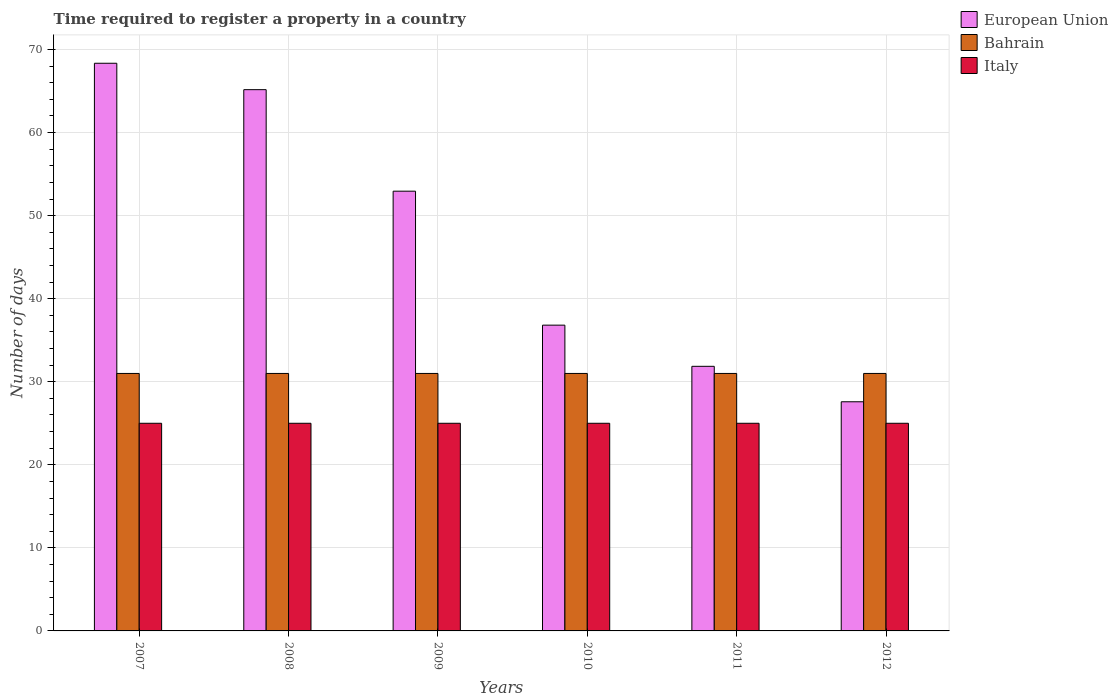How many groups of bars are there?
Offer a terse response. 6. How many bars are there on the 6th tick from the left?
Ensure brevity in your answer.  3. How many bars are there on the 6th tick from the right?
Keep it short and to the point. 3. What is the label of the 2nd group of bars from the left?
Your response must be concise. 2008. Across all years, what is the maximum number of days required to register a property in Bahrain?
Your answer should be very brief. 31. Across all years, what is the minimum number of days required to register a property in European Union?
Your response must be concise. 27.59. In which year was the number of days required to register a property in Italy maximum?
Ensure brevity in your answer.  2007. What is the total number of days required to register a property in European Union in the graph?
Your response must be concise. 282.72. What is the difference between the number of days required to register a property in Bahrain in 2009 and that in 2010?
Give a very brief answer. 0. What is the difference between the number of days required to register a property in Italy in 2007 and the number of days required to register a property in European Union in 2010?
Make the answer very short. -11.81. In the year 2008, what is the difference between the number of days required to register a property in European Union and number of days required to register a property in Bahrain?
Offer a terse response. 34.17. What is the ratio of the number of days required to register a property in European Union in 2011 to that in 2012?
Your response must be concise. 1.15. Is the number of days required to register a property in Italy in 2008 less than that in 2010?
Your answer should be very brief. No. Is the difference between the number of days required to register a property in European Union in 2007 and 2012 greater than the difference between the number of days required to register a property in Bahrain in 2007 and 2012?
Provide a succinct answer. Yes. What is the difference between the highest and the second highest number of days required to register a property in Bahrain?
Give a very brief answer. 0. What is the difference between the highest and the lowest number of days required to register a property in Italy?
Provide a succinct answer. 0. Is the sum of the number of days required to register a property in Bahrain in 2011 and 2012 greater than the maximum number of days required to register a property in Italy across all years?
Offer a very short reply. Yes. Is it the case that in every year, the sum of the number of days required to register a property in Italy and number of days required to register a property in European Union is greater than the number of days required to register a property in Bahrain?
Keep it short and to the point. Yes. How many bars are there?
Provide a succinct answer. 18. Are all the bars in the graph horizontal?
Ensure brevity in your answer.  No. How many years are there in the graph?
Your answer should be compact. 6. How many legend labels are there?
Make the answer very short. 3. What is the title of the graph?
Offer a very short reply. Time required to register a property in a country. What is the label or title of the X-axis?
Provide a succinct answer. Years. What is the label or title of the Y-axis?
Ensure brevity in your answer.  Number of days. What is the Number of days of European Union in 2007?
Keep it short and to the point. 68.35. What is the Number of days in Bahrain in 2007?
Your response must be concise. 31. What is the Number of days of Italy in 2007?
Your response must be concise. 25. What is the Number of days of European Union in 2008?
Offer a very short reply. 65.17. What is the Number of days in Italy in 2008?
Provide a short and direct response. 25. What is the Number of days of European Union in 2009?
Provide a short and direct response. 52.94. What is the Number of days of Bahrain in 2009?
Your answer should be compact. 31. What is the Number of days in Italy in 2009?
Make the answer very short. 25. What is the Number of days in European Union in 2010?
Your response must be concise. 36.81. What is the Number of days in European Union in 2011?
Your answer should be compact. 31.86. What is the Number of days of Italy in 2011?
Provide a succinct answer. 25. What is the Number of days of European Union in 2012?
Give a very brief answer. 27.59. Across all years, what is the maximum Number of days in European Union?
Your response must be concise. 68.35. Across all years, what is the minimum Number of days in European Union?
Provide a short and direct response. 27.59. Across all years, what is the minimum Number of days in Bahrain?
Offer a terse response. 31. Across all years, what is the minimum Number of days in Italy?
Your response must be concise. 25. What is the total Number of days in European Union in the graph?
Provide a short and direct response. 282.72. What is the total Number of days of Bahrain in the graph?
Your answer should be compact. 186. What is the total Number of days of Italy in the graph?
Make the answer very short. 150. What is the difference between the Number of days in European Union in 2007 and that in 2008?
Offer a terse response. 3.18. What is the difference between the Number of days of Bahrain in 2007 and that in 2008?
Provide a succinct answer. 0. What is the difference between the Number of days of European Union in 2007 and that in 2009?
Keep it short and to the point. 15.4. What is the difference between the Number of days in European Union in 2007 and that in 2010?
Your answer should be compact. 31.53. What is the difference between the Number of days in European Union in 2007 and that in 2011?
Your answer should be very brief. 36.49. What is the difference between the Number of days of Bahrain in 2007 and that in 2011?
Offer a terse response. 0. What is the difference between the Number of days of Italy in 2007 and that in 2011?
Offer a terse response. 0. What is the difference between the Number of days in European Union in 2007 and that in 2012?
Provide a succinct answer. 40.76. What is the difference between the Number of days in Bahrain in 2007 and that in 2012?
Make the answer very short. 0. What is the difference between the Number of days in Italy in 2007 and that in 2012?
Your response must be concise. 0. What is the difference between the Number of days in European Union in 2008 and that in 2009?
Give a very brief answer. 12.22. What is the difference between the Number of days in European Union in 2008 and that in 2010?
Keep it short and to the point. 28.35. What is the difference between the Number of days in European Union in 2008 and that in 2011?
Offer a terse response. 33.31. What is the difference between the Number of days in Bahrain in 2008 and that in 2011?
Ensure brevity in your answer.  0. What is the difference between the Number of days in European Union in 2008 and that in 2012?
Offer a terse response. 37.58. What is the difference between the Number of days in Bahrain in 2008 and that in 2012?
Give a very brief answer. 0. What is the difference between the Number of days of Italy in 2008 and that in 2012?
Your answer should be very brief. 0. What is the difference between the Number of days of European Union in 2009 and that in 2010?
Make the answer very short. 16.13. What is the difference between the Number of days in Bahrain in 2009 and that in 2010?
Give a very brief answer. 0. What is the difference between the Number of days of Italy in 2009 and that in 2010?
Give a very brief answer. 0. What is the difference between the Number of days in European Union in 2009 and that in 2011?
Give a very brief answer. 21.09. What is the difference between the Number of days in Italy in 2009 and that in 2011?
Offer a very short reply. 0. What is the difference between the Number of days in European Union in 2009 and that in 2012?
Ensure brevity in your answer.  25.36. What is the difference between the Number of days of European Union in 2010 and that in 2011?
Make the answer very short. 4.96. What is the difference between the Number of days in Bahrain in 2010 and that in 2011?
Make the answer very short. 0. What is the difference between the Number of days in Italy in 2010 and that in 2011?
Your answer should be compact. 0. What is the difference between the Number of days in European Union in 2010 and that in 2012?
Your response must be concise. 9.23. What is the difference between the Number of days in Italy in 2010 and that in 2012?
Ensure brevity in your answer.  0. What is the difference between the Number of days of European Union in 2011 and that in 2012?
Make the answer very short. 4.27. What is the difference between the Number of days in Italy in 2011 and that in 2012?
Offer a terse response. 0. What is the difference between the Number of days in European Union in 2007 and the Number of days in Bahrain in 2008?
Provide a succinct answer. 37.35. What is the difference between the Number of days of European Union in 2007 and the Number of days of Italy in 2008?
Your answer should be compact. 43.35. What is the difference between the Number of days of Bahrain in 2007 and the Number of days of Italy in 2008?
Ensure brevity in your answer.  6. What is the difference between the Number of days of European Union in 2007 and the Number of days of Bahrain in 2009?
Your response must be concise. 37.35. What is the difference between the Number of days in European Union in 2007 and the Number of days in Italy in 2009?
Offer a terse response. 43.35. What is the difference between the Number of days in Bahrain in 2007 and the Number of days in Italy in 2009?
Offer a terse response. 6. What is the difference between the Number of days of European Union in 2007 and the Number of days of Bahrain in 2010?
Your answer should be compact. 37.35. What is the difference between the Number of days of European Union in 2007 and the Number of days of Italy in 2010?
Provide a short and direct response. 43.35. What is the difference between the Number of days in European Union in 2007 and the Number of days in Bahrain in 2011?
Ensure brevity in your answer.  37.35. What is the difference between the Number of days in European Union in 2007 and the Number of days in Italy in 2011?
Offer a terse response. 43.35. What is the difference between the Number of days in European Union in 2007 and the Number of days in Bahrain in 2012?
Your answer should be very brief. 37.35. What is the difference between the Number of days of European Union in 2007 and the Number of days of Italy in 2012?
Provide a succinct answer. 43.35. What is the difference between the Number of days in European Union in 2008 and the Number of days in Bahrain in 2009?
Your answer should be compact. 34.17. What is the difference between the Number of days in European Union in 2008 and the Number of days in Italy in 2009?
Keep it short and to the point. 40.17. What is the difference between the Number of days in European Union in 2008 and the Number of days in Bahrain in 2010?
Your answer should be very brief. 34.17. What is the difference between the Number of days in European Union in 2008 and the Number of days in Italy in 2010?
Your answer should be compact. 40.17. What is the difference between the Number of days in European Union in 2008 and the Number of days in Bahrain in 2011?
Provide a short and direct response. 34.17. What is the difference between the Number of days in European Union in 2008 and the Number of days in Italy in 2011?
Offer a terse response. 40.17. What is the difference between the Number of days in European Union in 2008 and the Number of days in Bahrain in 2012?
Make the answer very short. 34.17. What is the difference between the Number of days of European Union in 2008 and the Number of days of Italy in 2012?
Provide a succinct answer. 40.17. What is the difference between the Number of days of Bahrain in 2008 and the Number of days of Italy in 2012?
Keep it short and to the point. 6. What is the difference between the Number of days of European Union in 2009 and the Number of days of Bahrain in 2010?
Your answer should be compact. 21.94. What is the difference between the Number of days of European Union in 2009 and the Number of days of Italy in 2010?
Ensure brevity in your answer.  27.94. What is the difference between the Number of days in Bahrain in 2009 and the Number of days in Italy in 2010?
Keep it short and to the point. 6. What is the difference between the Number of days in European Union in 2009 and the Number of days in Bahrain in 2011?
Make the answer very short. 21.94. What is the difference between the Number of days of European Union in 2009 and the Number of days of Italy in 2011?
Offer a very short reply. 27.94. What is the difference between the Number of days of Bahrain in 2009 and the Number of days of Italy in 2011?
Your answer should be compact. 6. What is the difference between the Number of days in European Union in 2009 and the Number of days in Bahrain in 2012?
Give a very brief answer. 21.94. What is the difference between the Number of days of European Union in 2009 and the Number of days of Italy in 2012?
Offer a very short reply. 27.94. What is the difference between the Number of days in European Union in 2010 and the Number of days in Bahrain in 2011?
Make the answer very short. 5.81. What is the difference between the Number of days of European Union in 2010 and the Number of days of Italy in 2011?
Provide a short and direct response. 11.81. What is the difference between the Number of days of European Union in 2010 and the Number of days of Bahrain in 2012?
Provide a short and direct response. 5.81. What is the difference between the Number of days of European Union in 2010 and the Number of days of Italy in 2012?
Provide a short and direct response. 11.81. What is the difference between the Number of days in Bahrain in 2010 and the Number of days in Italy in 2012?
Give a very brief answer. 6. What is the difference between the Number of days in European Union in 2011 and the Number of days in Bahrain in 2012?
Make the answer very short. 0.86. What is the difference between the Number of days in European Union in 2011 and the Number of days in Italy in 2012?
Give a very brief answer. 6.86. What is the average Number of days in European Union per year?
Ensure brevity in your answer.  47.12. In the year 2007, what is the difference between the Number of days of European Union and Number of days of Bahrain?
Your response must be concise. 37.35. In the year 2007, what is the difference between the Number of days in European Union and Number of days in Italy?
Provide a short and direct response. 43.35. In the year 2007, what is the difference between the Number of days of Bahrain and Number of days of Italy?
Give a very brief answer. 6. In the year 2008, what is the difference between the Number of days of European Union and Number of days of Bahrain?
Your response must be concise. 34.17. In the year 2008, what is the difference between the Number of days of European Union and Number of days of Italy?
Keep it short and to the point. 40.17. In the year 2008, what is the difference between the Number of days in Bahrain and Number of days in Italy?
Offer a very short reply. 6. In the year 2009, what is the difference between the Number of days in European Union and Number of days in Bahrain?
Keep it short and to the point. 21.94. In the year 2009, what is the difference between the Number of days of European Union and Number of days of Italy?
Your response must be concise. 27.94. In the year 2009, what is the difference between the Number of days in Bahrain and Number of days in Italy?
Your answer should be very brief. 6. In the year 2010, what is the difference between the Number of days of European Union and Number of days of Bahrain?
Your answer should be very brief. 5.81. In the year 2010, what is the difference between the Number of days in European Union and Number of days in Italy?
Your answer should be compact. 11.81. In the year 2011, what is the difference between the Number of days of European Union and Number of days of Italy?
Your answer should be compact. 6.86. In the year 2012, what is the difference between the Number of days in European Union and Number of days in Bahrain?
Your response must be concise. -3.41. In the year 2012, what is the difference between the Number of days of European Union and Number of days of Italy?
Your answer should be compact. 2.59. In the year 2012, what is the difference between the Number of days in Bahrain and Number of days in Italy?
Offer a terse response. 6. What is the ratio of the Number of days in European Union in 2007 to that in 2008?
Your response must be concise. 1.05. What is the ratio of the Number of days in Bahrain in 2007 to that in 2008?
Your response must be concise. 1. What is the ratio of the Number of days of European Union in 2007 to that in 2009?
Ensure brevity in your answer.  1.29. What is the ratio of the Number of days of Bahrain in 2007 to that in 2009?
Make the answer very short. 1. What is the ratio of the Number of days of Italy in 2007 to that in 2009?
Your answer should be very brief. 1. What is the ratio of the Number of days of European Union in 2007 to that in 2010?
Give a very brief answer. 1.86. What is the ratio of the Number of days of Italy in 2007 to that in 2010?
Offer a very short reply. 1. What is the ratio of the Number of days in European Union in 2007 to that in 2011?
Your answer should be compact. 2.15. What is the ratio of the Number of days of Italy in 2007 to that in 2011?
Your response must be concise. 1. What is the ratio of the Number of days of European Union in 2007 to that in 2012?
Keep it short and to the point. 2.48. What is the ratio of the Number of days in Bahrain in 2007 to that in 2012?
Make the answer very short. 1. What is the ratio of the Number of days of Italy in 2007 to that in 2012?
Ensure brevity in your answer.  1. What is the ratio of the Number of days of European Union in 2008 to that in 2009?
Keep it short and to the point. 1.23. What is the ratio of the Number of days of European Union in 2008 to that in 2010?
Your answer should be very brief. 1.77. What is the ratio of the Number of days in Bahrain in 2008 to that in 2010?
Ensure brevity in your answer.  1. What is the ratio of the Number of days in European Union in 2008 to that in 2011?
Your answer should be compact. 2.05. What is the ratio of the Number of days of Bahrain in 2008 to that in 2011?
Provide a short and direct response. 1. What is the ratio of the Number of days in European Union in 2008 to that in 2012?
Your response must be concise. 2.36. What is the ratio of the Number of days in Bahrain in 2008 to that in 2012?
Ensure brevity in your answer.  1. What is the ratio of the Number of days of European Union in 2009 to that in 2010?
Offer a very short reply. 1.44. What is the ratio of the Number of days of Italy in 2009 to that in 2010?
Offer a terse response. 1. What is the ratio of the Number of days of European Union in 2009 to that in 2011?
Provide a succinct answer. 1.66. What is the ratio of the Number of days of Bahrain in 2009 to that in 2011?
Provide a succinct answer. 1. What is the ratio of the Number of days in Italy in 2009 to that in 2011?
Your answer should be very brief. 1. What is the ratio of the Number of days of European Union in 2009 to that in 2012?
Offer a terse response. 1.92. What is the ratio of the Number of days of European Union in 2010 to that in 2011?
Ensure brevity in your answer.  1.16. What is the ratio of the Number of days of Italy in 2010 to that in 2011?
Provide a short and direct response. 1. What is the ratio of the Number of days in European Union in 2010 to that in 2012?
Your response must be concise. 1.33. What is the ratio of the Number of days of Bahrain in 2010 to that in 2012?
Make the answer very short. 1. What is the ratio of the Number of days of European Union in 2011 to that in 2012?
Give a very brief answer. 1.15. What is the difference between the highest and the second highest Number of days in European Union?
Your response must be concise. 3.18. What is the difference between the highest and the second highest Number of days of Italy?
Your response must be concise. 0. What is the difference between the highest and the lowest Number of days in European Union?
Provide a short and direct response. 40.76. 